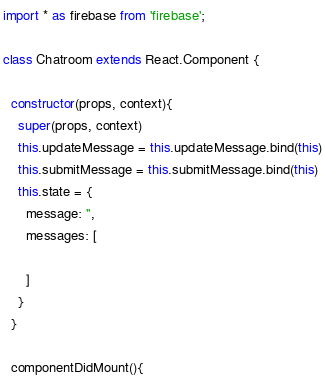Convert code to text. <code><loc_0><loc_0><loc_500><loc_500><_JavaScript_>import * as firebase from 'firebase';

class Chatroom extends React.Component {

  constructor(props, context){
    super(props, context)
    this.updateMessage = this.updateMessage.bind(this)
    this.submitMessage = this.submitMessage.bind(this)
    this.state = {
      message: '',
      messages: [

      ]
    }
  }

  componentDidMount(){</code> 